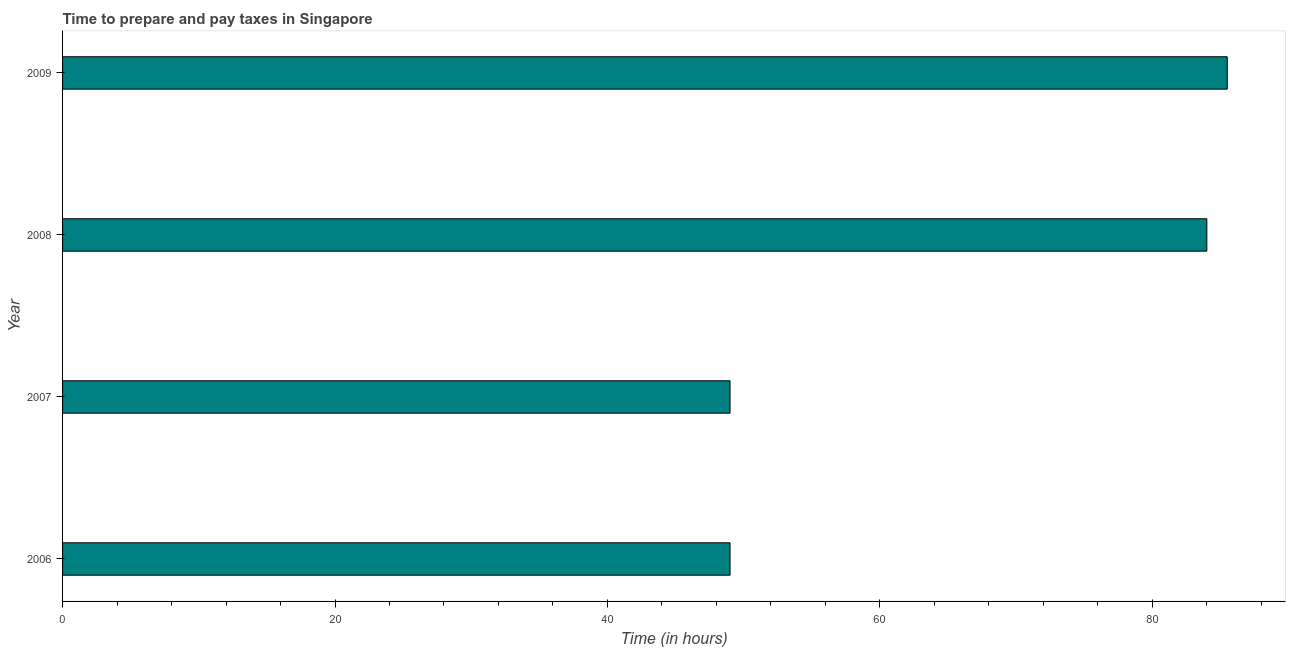What is the title of the graph?
Offer a very short reply. Time to prepare and pay taxes in Singapore. What is the label or title of the X-axis?
Ensure brevity in your answer.  Time (in hours). What is the label or title of the Y-axis?
Make the answer very short. Year. Across all years, what is the maximum time to prepare and pay taxes?
Offer a very short reply. 85.5. Across all years, what is the minimum time to prepare and pay taxes?
Your answer should be compact. 49. In which year was the time to prepare and pay taxes minimum?
Make the answer very short. 2006. What is the sum of the time to prepare and pay taxes?
Ensure brevity in your answer.  267.5. What is the difference between the time to prepare and pay taxes in 2007 and 2008?
Ensure brevity in your answer.  -35. What is the average time to prepare and pay taxes per year?
Provide a short and direct response. 66.88. What is the median time to prepare and pay taxes?
Your answer should be compact. 66.5. Do a majority of the years between 2008 and 2006 (inclusive) have time to prepare and pay taxes greater than 84 hours?
Ensure brevity in your answer.  Yes. What is the ratio of the time to prepare and pay taxes in 2006 to that in 2009?
Your answer should be compact. 0.57. Is the time to prepare and pay taxes in 2007 less than that in 2009?
Your answer should be very brief. Yes. Is the difference between the time to prepare and pay taxes in 2006 and 2009 greater than the difference between any two years?
Offer a terse response. Yes. What is the difference between the highest and the lowest time to prepare and pay taxes?
Give a very brief answer. 36.5. In how many years, is the time to prepare and pay taxes greater than the average time to prepare and pay taxes taken over all years?
Provide a short and direct response. 2. Are all the bars in the graph horizontal?
Provide a short and direct response. Yes. How many years are there in the graph?
Keep it short and to the point. 4. Are the values on the major ticks of X-axis written in scientific E-notation?
Your answer should be very brief. No. What is the Time (in hours) of 2006?
Your answer should be compact. 49. What is the Time (in hours) in 2007?
Make the answer very short. 49. What is the Time (in hours) in 2008?
Provide a succinct answer. 84. What is the Time (in hours) in 2009?
Your response must be concise. 85.5. What is the difference between the Time (in hours) in 2006 and 2008?
Make the answer very short. -35. What is the difference between the Time (in hours) in 2006 and 2009?
Keep it short and to the point. -36.5. What is the difference between the Time (in hours) in 2007 and 2008?
Offer a terse response. -35. What is the difference between the Time (in hours) in 2007 and 2009?
Your response must be concise. -36.5. What is the difference between the Time (in hours) in 2008 and 2009?
Provide a short and direct response. -1.5. What is the ratio of the Time (in hours) in 2006 to that in 2007?
Your answer should be compact. 1. What is the ratio of the Time (in hours) in 2006 to that in 2008?
Your answer should be compact. 0.58. What is the ratio of the Time (in hours) in 2006 to that in 2009?
Keep it short and to the point. 0.57. What is the ratio of the Time (in hours) in 2007 to that in 2008?
Offer a very short reply. 0.58. What is the ratio of the Time (in hours) in 2007 to that in 2009?
Keep it short and to the point. 0.57. 